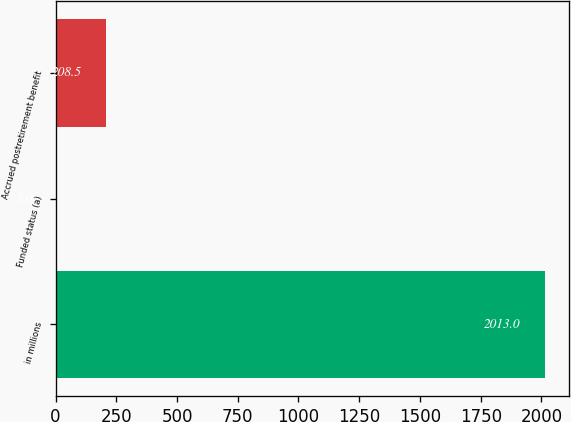<chart> <loc_0><loc_0><loc_500><loc_500><bar_chart><fcel>in millions<fcel>Funded status (a)<fcel>Accrued postretirement benefit<nl><fcel>2013<fcel>8<fcel>208.5<nl></chart> 